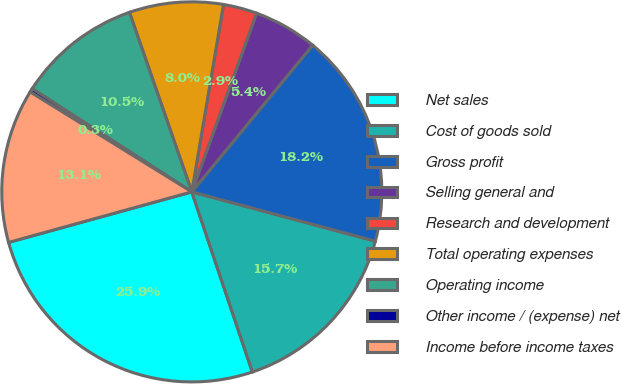Convert chart to OTSL. <chart><loc_0><loc_0><loc_500><loc_500><pie_chart><fcel>Net sales<fcel>Cost of goods sold<fcel>Gross profit<fcel>Selling general and<fcel>Research and development<fcel>Total operating expenses<fcel>Operating income<fcel>Other income / (expense) net<fcel>Income before income taxes<nl><fcel>25.88%<fcel>15.66%<fcel>18.21%<fcel>5.43%<fcel>2.87%<fcel>7.99%<fcel>10.54%<fcel>0.32%<fcel>13.1%<nl></chart> 